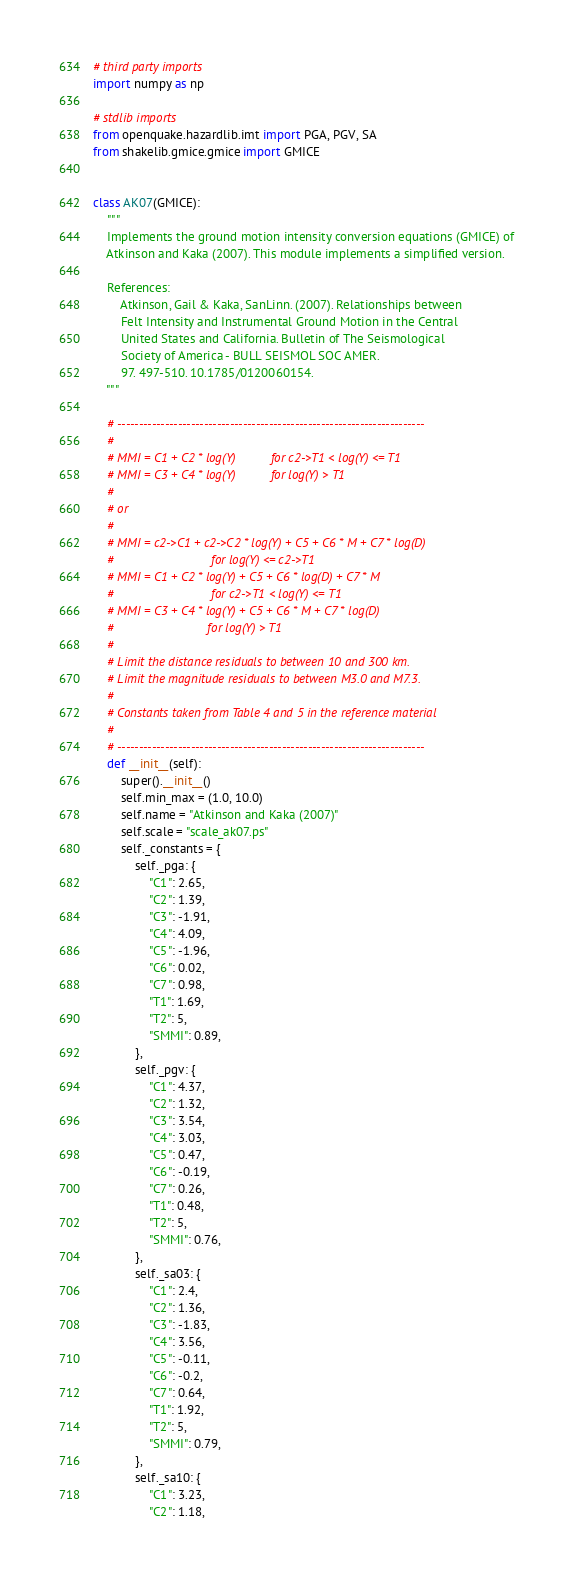<code> <loc_0><loc_0><loc_500><loc_500><_Python_># third party imports
import numpy as np

# stdlib imports
from openquake.hazardlib.imt import PGA, PGV, SA
from shakelib.gmice.gmice import GMICE


class AK07(GMICE):
    """
    Implements the ground motion intensity conversion equations (GMICE) of
    Atkinson and Kaka (2007). This module implements a simplified version.

    References:
        Atkinson, Gail & Kaka, SanLinn. (2007). Relationships between
        Felt Intensity and Instrumental Ground Motion in the Central
        United States and California. Bulletin of The Seismological
        Society of America - BULL SEISMOL SOC AMER.
        97. 497-510. 10.1785/0120060154.
    """

    # -----------------------------------------------------------------------
    #
    # MMI = C1 + C2 * log(Y)          for c2->T1 < log(Y) <= T1
    # MMI = C3 + C4 * log(Y)          for log(Y) > T1
    #
    # or
    #
    # MMI = c2->C1 + c2->C2 * log(Y) + C5 + C6 * M + C7 * log(D)
    #                            for log(Y) <= c2->T1
    # MMI = C1 + C2 * log(Y) + C5 + C6 * log(D) + C7 * M
    #                            for c2->T1 < log(Y) <= T1
    # MMI = C3 + C4 * log(Y) + C5 + C6 * M + C7 * log(D)
    #                           for log(Y) > T1
    #
    # Limit the distance residuals to between 10 and 300 km.
    # Limit the magnitude residuals to between M3.0 and M7.3.
    #
    # Constants taken from Table 4 and 5 in the reference material
    #
    # -----------------------------------------------------------------------
    def __init__(self):
        super().__init__()
        self.min_max = (1.0, 10.0)
        self.name = "Atkinson and Kaka (2007)"
        self.scale = "scale_ak07.ps"
        self._constants = {
            self._pga: {
                "C1": 2.65,
                "C2": 1.39,
                "C3": -1.91,
                "C4": 4.09,
                "C5": -1.96,
                "C6": 0.02,
                "C7": 0.98,
                "T1": 1.69,
                "T2": 5,
                "SMMI": 0.89,
            },
            self._pgv: {
                "C1": 4.37,
                "C2": 1.32,
                "C3": 3.54,
                "C4": 3.03,
                "C5": 0.47,
                "C6": -0.19,
                "C7": 0.26,
                "T1": 0.48,
                "T2": 5,
                "SMMI": 0.76,
            },
            self._sa03: {
                "C1": 2.4,
                "C2": 1.36,
                "C3": -1.83,
                "C4": 3.56,
                "C5": -0.11,
                "C6": -0.2,
                "C7": 0.64,
                "T1": 1.92,
                "T2": 5,
                "SMMI": 0.79,
            },
            self._sa10: {
                "C1": 3.23,
                "C2": 1.18,</code> 